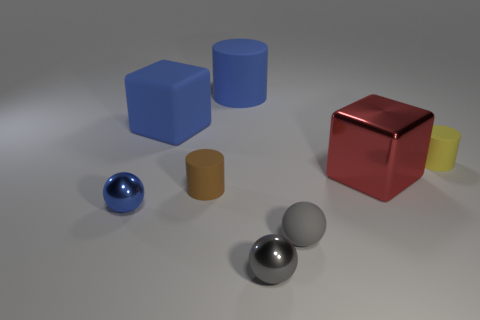Add 2 tiny blue objects. How many objects exist? 10 Subtract all spheres. How many objects are left? 5 Add 7 large red metallic cubes. How many large red metallic cubes are left? 8 Add 2 metal objects. How many metal objects exist? 5 Subtract 0 green cylinders. How many objects are left? 8 Subtract all tiny yellow matte cylinders. Subtract all metallic balls. How many objects are left? 5 